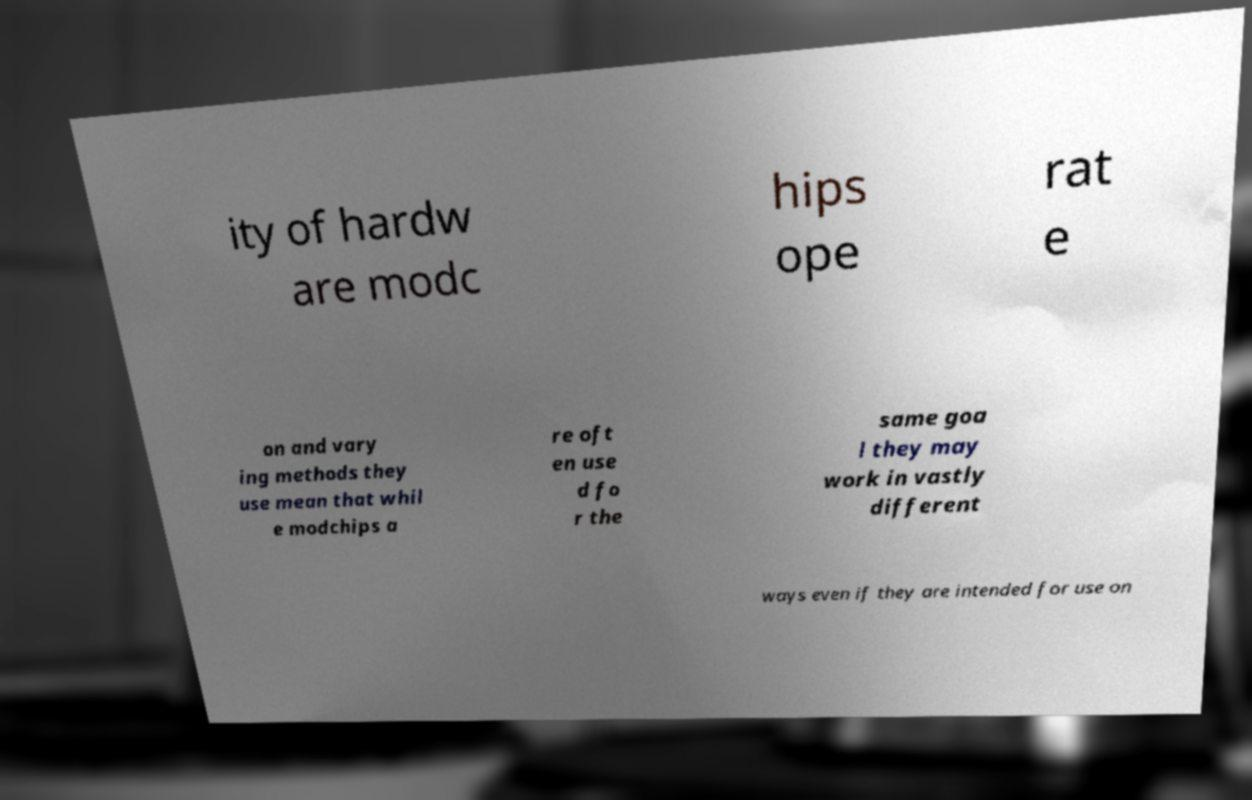What messages or text are displayed in this image? I need them in a readable, typed format. ity of hardw are modc hips ope rat e on and vary ing methods they use mean that whil e modchips a re oft en use d fo r the same goa l they may work in vastly different ways even if they are intended for use on 